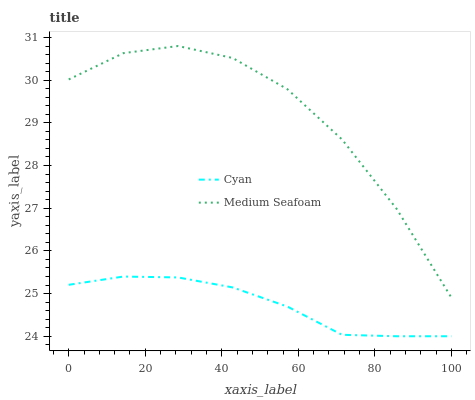Does Cyan have the minimum area under the curve?
Answer yes or no. Yes. Does Medium Seafoam have the maximum area under the curve?
Answer yes or no. Yes. Does Medium Seafoam have the minimum area under the curve?
Answer yes or no. No. Is Cyan the smoothest?
Answer yes or no. Yes. Is Medium Seafoam the roughest?
Answer yes or no. Yes. Is Medium Seafoam the smoothest?
Answer yes or no. No. Does Medium Seafoam have the lowest value?
Answer yes or no. No. Does Medium Seafoam have the highest value?
Answer yes or no. Yes. Is Cyan less than Medium Seafoam?
Answer yes or no. Yes. Is Medium Seafoam greater than Cyan?
Answer yes or no. Yes. Does Cyan intersect Medium Seafoam?
Answer yes or no. No. 